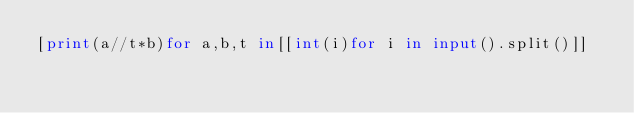<code> <loc_0><loc_0><loc_500><loc_500><_Python_>[print(a//t*b)for a,b,t in[[int(i)for i in input().split()]]</code> 